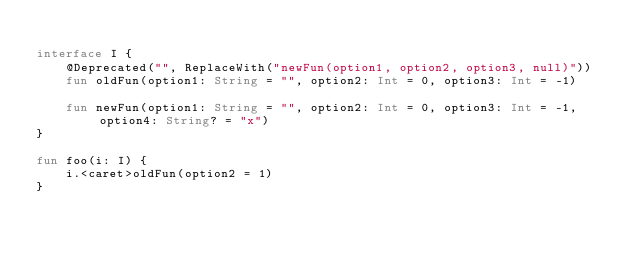<code> <loc_0><loc_0><loc_500><loc_500><_Kotlin_>
interface I {
    @Deprecated("", ReplaceWith("newFun(option1, option2, option3, null)"))
    fun oldFun(option1: String = "", option2: Int = 0, option3: Int = -1)

    fun newFun(option1: String = "", option2: Int = 0, option3: Int = -1, option4: String? = "x")
}

fun foo(i: I) {
    i.<caret>oldFun(option2 = 1)
}
</code> 